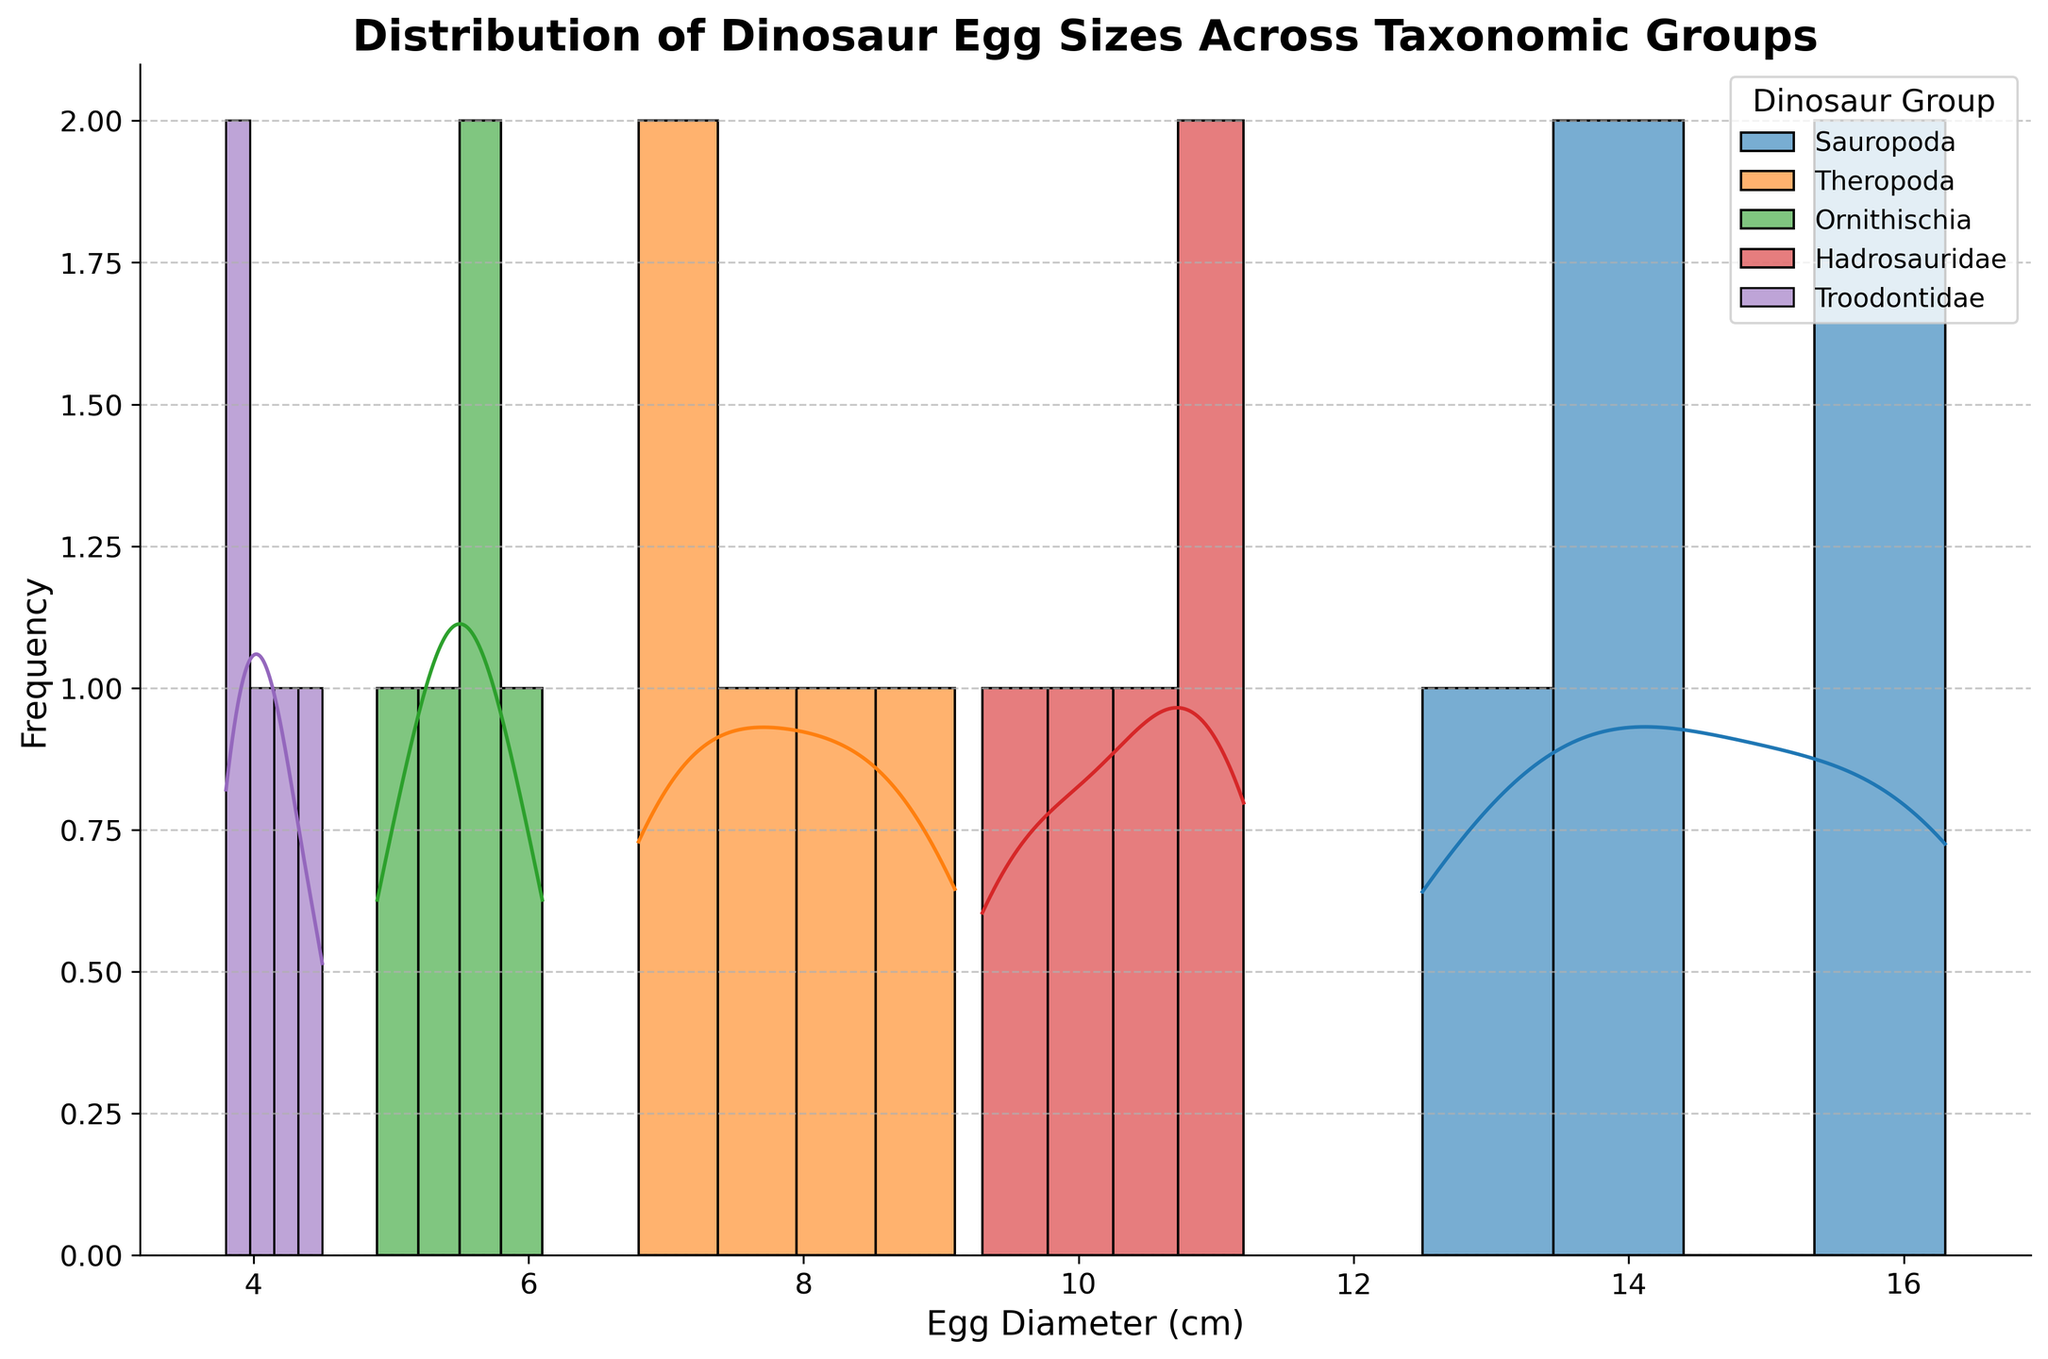What is the title of the figure? The title is written in bold at the top of the figure. It is "Distribution of Dinosaur Egg Sizes Across Taxonomic Groups".
Answer: Distribution of Dinosaur Egg Sizes Across Taxonomic Groups Which dinosaur group has the smallest average egg diameter? To find the smallest average, look at the density curves and the histogram centers. Troodontidae's density curve and histogram indicate smaller central values compared to other groups.
Answer: Troodontidae How do the egg sizes of Sauropoda and Theropoda compare? Compare the histograms and density curves of Sauropoda and Theropoda. Sauropoda’s egg sizes are larger, with densities peaking around the higher ranges, while Theropoda peaks lower.
Answer: Sauropoda eggs are larger than Theropoda Which dinosaur group shows the most variation in egg sizes? Variation can be observed by the spread of the density curve and histogram. Sauropoda eggs are spread over a wider range, indicating more variation.
Answer: Sauropoda What is the range of egg diameters for Hadrosauridae? Observe the Hadrosauridae histograms' spread from the smallest to the largest value. They range approximately from 9 cm to 11 cm.
Answer: 9 cm to 11 cm Which group appears to have the highest peak density? The highest peak density is the tallest point of the density curve. Theropoda has the highest peak density.
Answer: Theropoda Are any groups’ egg sizes overlapping significantly? Look for overlapping regions in the histograms and density curves. There is significant overlap between Hadrosauridae and Theropoda.
Answer: Yes, Hadrosauridae and Theropoda What is the approximate egg diameter where Troodontidae's density curve peaks? Observe where the highest point of the Troodontidae density curve occurs, which is around 4 cm.
Answer: 4 cm Between which two dinosaur groups is the difference in average egg diameter the greatest? Compare the central tendencies of each group's density curve. The difference is greatest between Sauropoda and Troodontidae.
Answer: Sauropoda and Troodontidae 